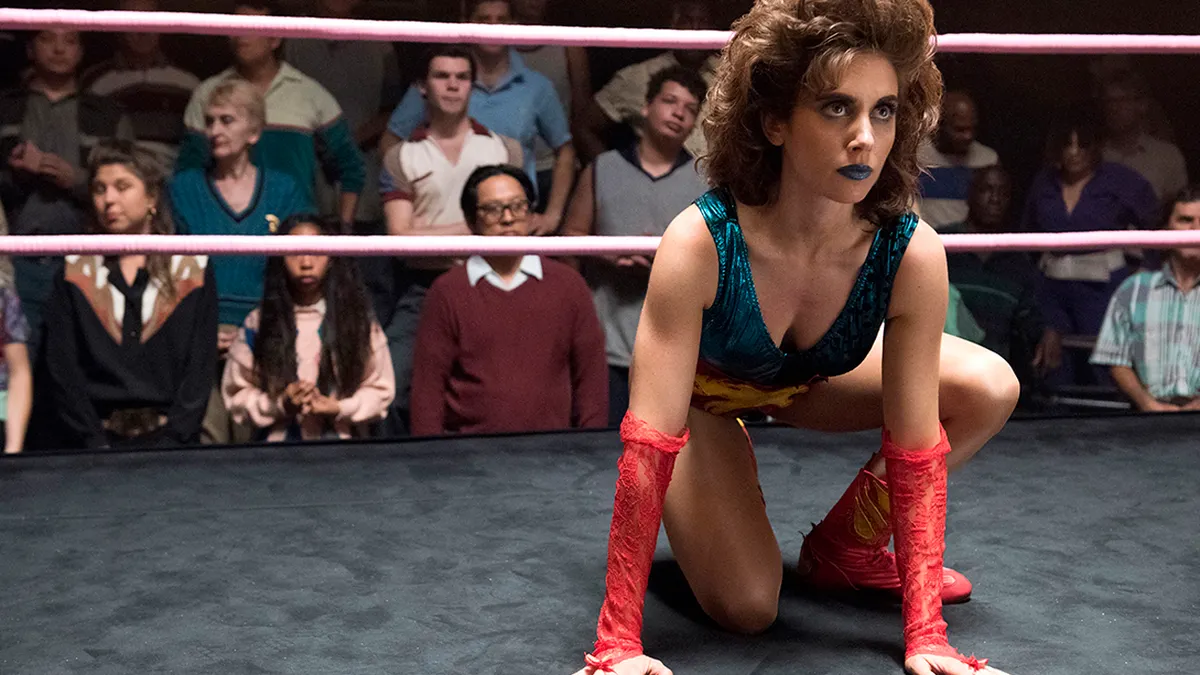Describe the atmosphere in the venue. The venue atmosphere is charged with excitement and anticipation. The spectators appear deeply engaged, with their eyes locked on the central ring action. The mix of shadows and spotlights converges on the wrestler, heightening the drama and focusing all energy on the unfolding event. 